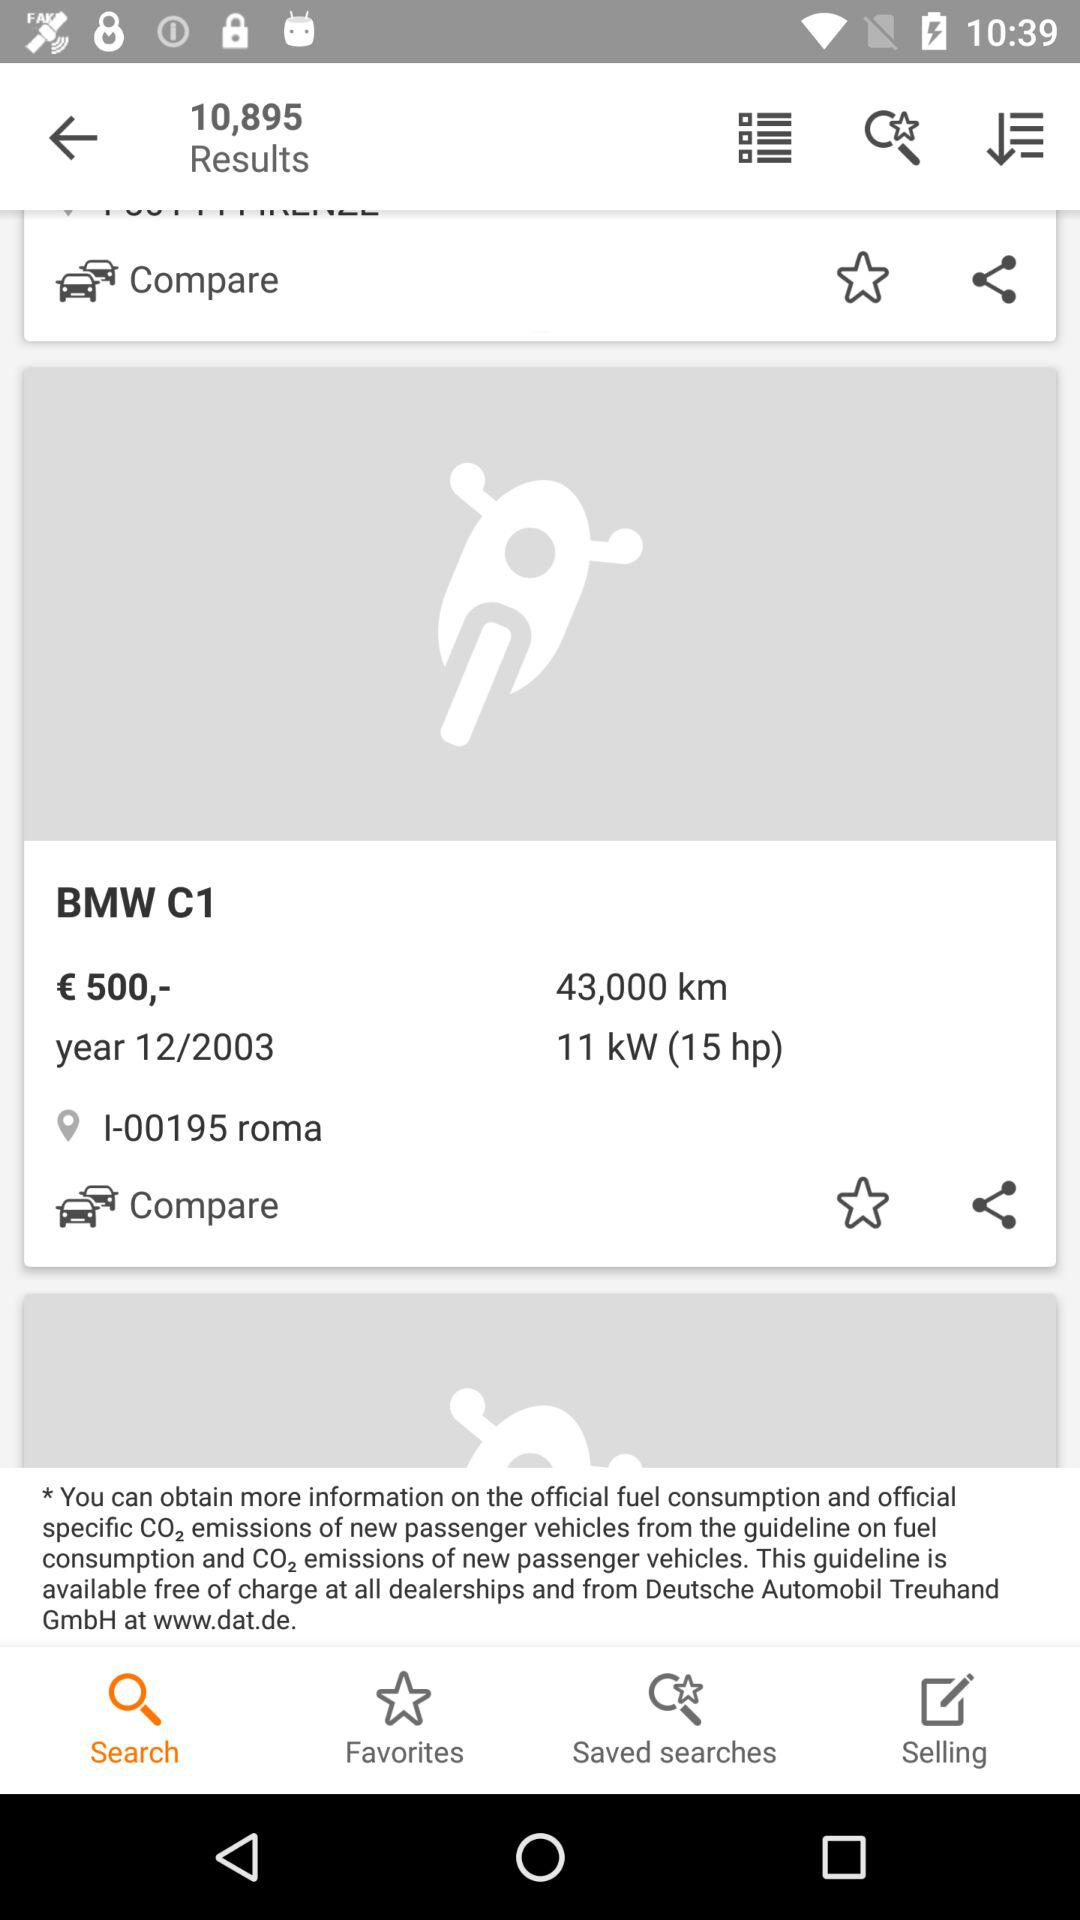What is the manufacturing year of the BMW C1? The manufacturing year is 2003. 